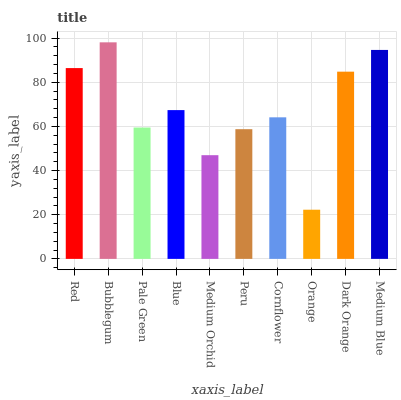Is Orange the minimum?
Answer yes or no. Yes. Is Bubblegum the maximum?
Answer yes or no. Yes. Is Pale Green the minimum?
Answer yes or no. No. Is Pale Green the maximum?
Answer yes or no. No. Is Bubblegum greater than Pale Green?
Answer yes or no. Yes. Is Pale Green less than Bubblegum?
Answer yes or no. Yes. Is Pale Green greater than Bubblegum?
Answer yes or no. No. Is Bubblegum less than Pale Green?
Answer yes or no. No. Is Blue the high median?
Answer yes or no. Yes. Is Cornflower the low median?
Answer yes or no. Yes. Is Pale Green the high median?
Answer yes or no. No. Is Dark Orange the low median?
Answer yes or no. No. 